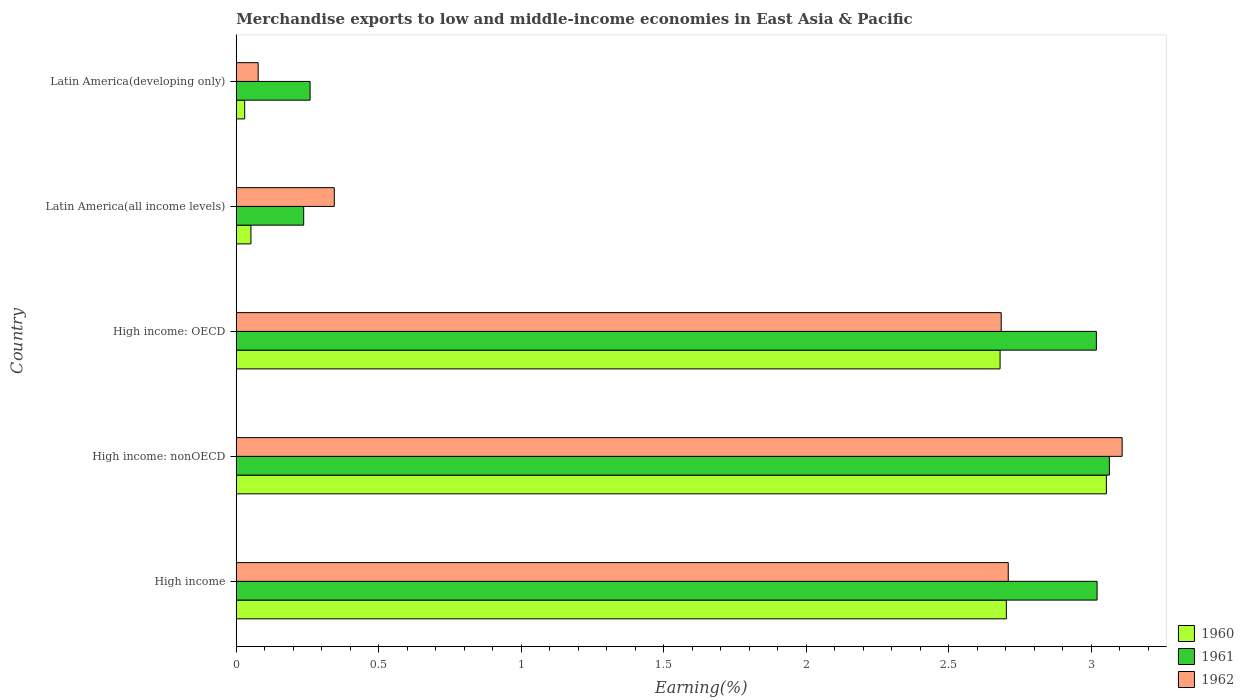How many different coloured bars are there?
Your response must be concise. 3. How many groups of bars are there?
Offer a very short reply. 5. How many bars are there on the 1st tick from the top?
Keep it short and to the point. 3. What is the label of the 2nd group of bars from the top?
Offer a very short reply. Latin America(all income levels). In how many cases, is the number of bars for a given country not equal to the number of legend labels?
Your answer should be compact. 0. What is the percentage of amount earned from merchandise exports in 1960 in High income: nonOECD?
Keep it short and to the point. 3.05. Across all countries, what is the maximum percentage of amount earned from merchandise exports in 1961?
Provide a short and direct response. 3.06. Across all countries, what is the minimum percentage of amount earned from merchandise exports in 1960?
Keep it short and to the point. 0.03. In which country was the percentage of amount earned from merchandise exports in 1961 maximum?
Your response must be concise. High income: nonOECD. In which country was the percentage of amount earned from merchandise exports in 1960 minimum?
Give a very brief answer. Latin America(developing only). What is the total percentage of amount earned from merchandise exports in 1962 in the graph?
Offer a very short reply. 8.92. What is the difference between the percentage of amount earned from merchandise exports in 1961 in Latin America(all income levels) and that in Latin America(developing only)?
Your answer should be compact. -0.02. What is the difference between the percentage of amount earned from merchandise exports in 1960 in High income: OECD and the percentage of amount earned from merchandise exports in 1961 in Latin America(all income levels)?
Your response must be concise. 2.44. What is the average percentage of amount earned from merchandise exports in 1961 per country?
Your response must be concise. 1.92. What is the difference between the percentage of amount earned from merchandise exports in 1960 and percentage of amount earned from merchandise exports in 1962 in High income?
Your answer should be very brief. -0.01. In how many countries, is the percentage of amount earned from merchandise exports in 1961 greater than 1 %?
Your answer should be very brief. 3. What is the ratio of the percentage of amount earned from merchandise exports in 1961 in High income to that in Latin America(all income levels)?
Your answer should be very brief. 12.76. Is the difference between the percentage of amount earned from merchandise exports in 1960 in High income: OECD and Latin America(all income levels) greater than the difference between the percentage of amount earned from merchandise exports in 1962 in High income: OECD and Latin America(all income levels)?
Provide a succinct answer. Yes. What is the difference between the highest and the second highest percentage of amount earned from merchandise exports in 1960?
Give a very brief answer. 0.35. What is the difference between the highest and the lowest percentage of amount earned from merchandise exports in 1960?
Offer a terse response. 3.02. What does the 1st bar from the top in High income: nonOECD represents?
Ensure brevity in your answer.  1962. What does the 2nd bar from the bottom in High income: nonOECD represents?
Provide a succinct answer. 1961. How many bars are there?
Give a very brief answer. 15. Are all the bars in the graph horizontal?
Keep it short and to the point. Yes. How many countries are there in the graph?
Offer a terse response. 5. What is the difference between two consecutive major ticks on the X-axis?
Offer a very short reply. 0.5. How many legend labels are there?
Your answer should be compact. 3. How are the legend labels stacked?
Make the answer very short. Vertical. What is the title of the graph?
Give a very brief answer. Merchandise exports to low and middle-income economies in East Asia & Pacific. Does "1966" appear as one of the legend labels in the graph?
Make the answer very short. No. What is the label or title of the X-axis?
Keep it short and to the point. Earning(%). What is the label or title of the Y-axis?
Give a very brief answer. Country. What is the Earning(%) in 1960 in High income?
Provide a short and direct response. 2.7. What is the Earning(%) of 1961 in High income?
Give a very brief answer. 3.02. What is the Earning(%) in 1962 in High income?
Provide a succinct answer. 2.71. What is the Earning(%) of 1960 in High income: nonOECD?
Your answer should be very brief. 3.05. What is the Earning(%) in 1961 in High income: nonOECD?
Make the answer very short. 3.06. What is the Earning(%) in 1962 in High income: nonOECD?
Keep it short and to the point. 3.11. What is the Earning(%) of 1960 in High income: OECD?
Ensure brevity in your answer.  2.68. What is the Earning(%) in 1961 in High income: OECD?
Provide a short and direct response. 3.02. What is the Earning(%) of 1962 in High income: OECD?
Your answer should be very brief. 2.68. What is the Earning(%) in 1960 in Latin America(all income levels)?
Offer a very short reply. 0.05. What is the Earning(%) of 1961 in Latin America(all income levels)?
Keep it short and to the point. 0.24. What is the Earning(%) of 1962 in Latin America(all income levels)?
Offer a terse response. 0.34. What is the Earning(%) of 1960 in Latin America(developing only)?
Your answer should be compact. 0.03. What is the Earning(%) in 1961 in Latin America(developing only)?
Make the answer very short. 0.26. What is the Earning(%) of 1962 in Latin America(developing only)?
Provide a short and direct response. 0.08. Across all countries, what is the maximum Earning(%) in 1960?
Keep it short and to the point. 3.05. Across all countries, what is the maximum Earning(%) in 1961?
Your answer should be compact. 3.06. Across all countries, what is the maximum Earning(%) of 1962?
Your answer should be compact. 3.11. Across all countries, what is the minimum Earning(%) of 1960?
Offer a very short reply. 0.03. Across all countries, what is the minimum Earning(%) of 1961?
Provide a succinct answer. 0.24. Across all countries, what is the minimum Earning(%) of 1962?
Keep it short and to the point. 0.08. What is the total Earning(%) of 1960 in the graph?
Offer a very short reply. 8.52. What is the total Earning(%) in 1961 in the graph?
Offer a terse response. 9.6. What is the total Earning(%) of 1962 in the graph?
Ensure brevity in your answer.  8.92. What is the difference between the Earning(%) of 1960 in High income and that in High income: nonOECD?
Ensure brevity in your answer.  -0.35. What is the difference between the Earning(%) of 1961 in High income and that in High income: nonOECD?
Offer a very short reply. -0.04. What is the difference between the Earning(%) of 1962 in High income and that in High income: nonOECD?
Offer a terse response. -0.4. What is the difference between the Earning(%) in 1960 in High income and that in High income: OECD?
Give a very brief answer. 0.02. What is the difference between the Earning(%) in 1961 in High income and that in High income: OECD?
Keep it short and to the point. 0. What is the difference between the Earning(%) in 1962 in High income and that in High income: OECD?
Your answer should be compact. 0.02. What is the difference between the Earning(%) of 1960 in High income and that in Latin America(all income levels)?
Keep it short and to the point. 2.65. What is the difference between the Earning(%) of 1961 in High income and that in Latin America(all income levels)?
Make the answer very short. 2.78. What is the difference between the Earning(%) of 1962 in High income and that in Latin America(all income levels)?
Offer a terse response. 2.37. What is the difference between the Earning(%) of 1960 in High income and that in Latin America(developing only)?
Offer a terse response. 2.67. What is the difference between the Earning(%) of 1961 in High income and that in Latin America(developing only)?
Ensure brevity in your answer.  2.76. What is the difference between the Earning(%) of 1962 in High income and that in Latin America(developing only)?
Your answer should be compact. 2.63. What is the difference between the Earning(%) in 1960 in High income: nonOECD and that in High income: OECD?
Keep it short and to the point. 0.37. What is the difference between the Earning(%) of 1961 in High income: nonOECD and that in High income: OECD?
Ensure brevity in your answer.  0.05. What is the difference between the Earning(%) in 1962 in High income: nonOECD and that in High income: OECD?
Give a very brief answer. 0.42. What is the difference between the Earning(%) of 1960 in High income: nonOECD and that in Latin America(all income levels)?
Offer a very short reply. 3. What is the difference between the Earning(%) of 1961 in High income: nonOECD and that in Latin America(all income levels)?
Give a very brief answer. 2.83. What is the difference between the Earning(%) of 1962 in High income: nonOECD and that in Latin America(all income levels)?
Provide a short and direct response. 2.76. What is the difference between the Earning(%) in 1960 in High income: nonOECD and that in Latin America(developing only)?
Offer a very short reply. 3.02. What is the difference between the Earning(%) of 1961 in High income: nonOECD and that in Latin America(developing only)?
Keep it short and to the point. 2.8. What is the difference between the Earning(%) of 1962 in High income: nonOECD and that in Latin America(developing only)?
Keep it short and to the point. 3.03. What is the difference between the Earning(%) of 1960 in High income: OECD and that in Latin America(all income levels)?
Give a very brief answer. 2.63. What is the difference between the Earning(%) of 1961 in High income: OECD and that in Latin America(all income levels)?
Give a very brief answer. 2.78. What is the difference between the Earning(%) of 1962 in High income: OECD and that in Latin America(all income levels)?
Make the answer very short. 2.34. What is the difference between the Earning(%) of 1960 in High income: OECD and that in Latin America(developing only)?
Provide a short and direct response. 2.65. What is the difference between the Earning(%) of 1961 in High income: OECD and that in Latin America(developing only)?
Your response must be concise. 2.76. What is the difference between the Earning(%) of 1962 in High income: OECD and that in Latin America(developing only)?
Your answer should be compact. 2.61. What is the difference between the Earning(%) of 1960 in Latin America(all income levels) and that in Latin America(developing only)?
Keep it short and to the point. 0.02. What is the difference between the Earning(%) of 1961 in Latin America(all income levels) and that in Latin America(developing only)?
Keep it short and to the point. -0.02. What is the difference between the Earning(%) of 1962 in Latin America(all income levels) and that in Latin America(developing only)?
Keep it short and to the point. 0.27. What is the difference between the Earning(%) in 1960 in High income and the Earning(%) in 1961 in High income: nonOECD?
Keep it short and to the point. -0.36. What is the difference between the Earning(%) of 1960 in High income and the Earning(%) of 1962 in High income: nonOECD?
Provide a succinct answer. -0.41. What is the difference between the Earning(%) in 1961 in High income and the Earning(%) in 1962 in High income: nonOECD?
Provide a short and direct response. -0.09. What is the difference between the Earning(%) in 1960 in High income and the Earning(%) in 1961 in High income: OECD?
Your answer should be compact. -0.32. What is the difference between the Earning(%) of 1960 in High income and the Earning(%) of 1962 in High income: OECD?
Ensure brevity in your answer.  0.02. What is the difference between the Earning(%) in 1961 in High income and the Earning(%) in 1962 in High income: OECD?
Provide a succinct answer. 0.34. What is the difference between the Earning(%) in 1960 in High income and the Earning(%) in 1961 in Latin America(all income levels)?
Give a very brief answer. 2.47. What is the difference between the Earning(%) in 1960 in High income and the Earning(%) in 1962 in Latin America(all income levels)?
Offer a very short reply. 2.36. What is the difference between the Earning(%) of 1961 in High income and the Earning(%) of 1962 in Latin America(all income levels)?
Ensure brevity in your answer.  2.68. What is the difference between the Earning(%) of 1960 in High income and the Earning(%) of 1961 in Latin America(developing only)?
Ensure brevity in your answer.  2.44. What is the difference between the Earning(%) of 1960 in High income and the Earning(%) of 1962 in Latin America(developing only)?
Your answer should be compact. 2.63. What is the difference between the Earning(%) of 1961 in High income and the Earning(%) of 1962 in Latin America(developing only)?
Your answer should be compact. 2.94. What is the difference between the Earning(%) in 1960 in High income: nonOECD and the Earning(%) in 1961 in High income: OECD?
Provide a succinct answer. 0.04. What is the difference between the Earning(%) of 1960 in High income: nonOECD and the Earning(%) of 1962 in High income: OECD?
Offer a terse response. 0.37. What is the difference between the Earning(%) of 1961 in High income: nonOECD and the Earning(%) of 1962 in High income: OECD?
Provide a short and direct response. 0.38. What is the difference between the Earning(%) in 1960 in High income: nonOECD and the Earning(%) in 1961 in Latin America(all income levels)?
Offer a very short reply. 2.82. What is the difference between the Earning(%) of 1960 in High income: nonOECD and the Earning(%) of 1962 in Latin America(all income levels)?
Your response must be concise. 2.71. What is the difference between the Earning(%) of 1961 in High income: nonOECD and the Earning(%) of 1962 in Latin America(all income levels)?
Provide a short and direct response. 2.72. What is the difference between the Earning(%) in 1960 in High income: nonOECD and the Earning(%) in 1961 in Latin America(developing only)?
Your response must be concise. 2.79. What is the difference between the Earning(%) in 1960 in High income: nonOECD and the Earning(%) in 1962 in Latin America(developing only)?
Provide a short and direct response. 2.98. What is the difference between the Earning(%) in 1961 in High income: nonOECD and the Earning(%) in 1962 in Latin America(developing only)?
Ensure brevity in your answer.  2.99. What is the difference between the Earning(%) of 1960 in High income: OECD and the Earning(%) of 1961 in Latin America(all income levels)?
Offer a very short reply. 2.44. What is the difference between the Earning(%) in 1960 in High income: OECD and the Earning(%) in 1962 in Latin America(all income levels)?
Keep it short and to the point. 2.34. What is the difference between the Earning(%) in 1961 in High income: OECD and the Earning(%) in 1962 in Latin America(all income levels)?
Your answer should be compact. 2.67. What is the difference between the Earning(%) in 1960 in High income: OECD and the Earning(%) in 1961 in Latin America(developing only)?
Provide a short and direct response. 2.42. What is the difference between the Earning(%) in 1960 in High income: OECD and the Earning(%) in 1962 in Latin America(developing only)?
Provide a succinct answer. 2.6. What is the difference between the Earning(%) of 1961 in High income: OECD and the Earning(%) of 1962 in Latin America(developing only)?
Your answer should be very brief. 2.94. What is the difference between the Earning(%) in 1960 in Latin America(all income levels) and the Earning(%) in 1961 in Latin America(developing only)?
Give a very brief answer. -0.21. What is the difference between the Earning(%) in 1960 in Latin America(all income levels) and the Earning(%) in 1962 in Latin America(developing only)?
Provide a succinct answer. -0.03. What is the difference between the Earning(%) in 1961 in Latin America(all income levels) and the Earning(%) in 1962 in Latin America(developing only)?
Provide a short and direct response. 0.16. What is the average Earning(%) in 1960 per country?
Provide a short and direct response. 1.7. What is the average Earning(%) in 1961 per country?
Provide a succinct answer. 1.92. What is the average Earning(%) of 1962 per country?
Offer a terse response. 1.78. What is the difference between the Earning(%) of 1960 and Earning(%) of 1961 in High income?
Ensure brevity in your answer.  -0.32. What is the difference between the Earning(%) of 1960 and Earning(%) of 1962 in High income?
Provide a succinct answer. -0.01. What is the difference between the Earning(%) of 1961 and Earning(%) of 1962 in High income?
Ensure brevity in your answer.  0.31. What is the difference between the Earning(%) of 1960 and Earning(%) of 1961 in High income: nonOECD?
Offer a very short reply. -0.01. What is the difference between the Earning(%) in 1960 and Earning(%) in 1962 in High income: nonOECD?
Provide a succinct answer. -0.06. What is the difference between the Earning(%) of 1961 and Earning(%) of 1962 in High income: nonOECD?
Keep it short and to the point. -0.04. What is the difference between the Earning(%) in 1960 and Earning(%) in 1961 in High income: OECD?
Offer a very short reply. -0.34. What is the difference between the Earning(%) of 1960 and Earning(%) of 1962 in High income: OECD?
Ensure brevity in your answer.  -0. What is the difference between the Earning(%) of 1961 and Earning(%) of 1962 in High income: OECD?
Keep it short and to the point. 0.33. What is the difference between the Earning(%) in 1960 and Earning(%) in 1961 in Latin America(all income levels)?
Provide a short and direct response. -0.19. What is the difference between the Earning(%) in 1960 and Earning(%) in 1962 in Latin America(all income levels)?
Your answer should be very brief. -0.29. What is the difference between the Earning(%) of 1961 and Earning(%) of 1962 in Latin America(all income levels)?
Your response must be concise. -0.11. What is the difference between the Earning(%) of 1960 and Earning(%) of 1961 in Latin America(developing only)?
Your answer should be very brief. -0.23. What is the difference between the Earning(%) of 1960 and Earning(%) of 1962 in Latin America(developing only)?
Give a very brief answer. -0.05. What is the difference between the Earning(%) in 1961 and Earning(%) in 1962 in Latin America(developing only)?
Keep it short and to the point. 0.18. What is the ratio of the Earning(%) of 1960 in High income to that in High income: nonOECD?
Offer a terse response. 0.89. What is the ratio of the Earning(%) of 1961 in High income to that in High income: nonOECD?
Your answer should be compact. 0.99. What is the ratio of the Earning(%) in 1962 in High income to that in High income: nonOECD?
Your answer should be compact. 0.87. What is the ratio of the Earning(%) of 1960 in High income to that in High income: OECD?
Provide a short and direct response. 1.01. What is the ratio of the Earning(%) in 1962 in High income to that in High income: OECD?
Keep it short and to the point. 1.01. What is the ratio of the Earning(%) of 1960 in High income to that in Latin America(all income levels)?
Offer a very short reply. 52.52. What is the ratio of the Earning(%) of 1961 in High income to that in Latin America(all income levels)?
Provide a succinct answer. 12.76. What is the ratio of the Earning(%) in 1962 in High income to that in Latin America(all income levels)?
Provide a short and direct response. 7.87. What is the ratio of the Earning(%) in 1960 in High income to that in Latin America(developing only)?
Your response must be concise. 91.3. What is the ratio of the Earning(%) of 1961 in High income to that in Latin America(developing only)?
Provide a succinct answer. 11.66. What is the ratio of the Earning(%) of 1962 in High income to that in Latin America(developing only)?
Offer a terse response. 35.22. What is the ratio of the Earning(%) in 1960 in High income: nonOECD to that in High income: OECD?
Give a very brief answer. 1.14. What is the ratio of the Earning(%) in 1961 in High income: nonOECD to that in High income: OECD?
Keep it short and to the point. 1.02. What is the ratio of the Earning(%) in 1962 in High income: nonOECD to that in High income: OECD?
Your answer should be very brief. 1.16. What is the ratio of the Earning(%) of 1960 in High income: nonOECD to that in Latin America(all income levels)?
Your answer should be compact. 59.34. What is the ratio of the Earning(%) in 1961 in High income: nonOECD to that in Latin America(all income levels)?
Ensure brevity in your answer.  12.95. What is the ratio of the Earning(%) in 1962 in High income: nonOECD to that in Latin America(all income levels)?
Provide a succinct answer. 9.04. What is the ratio of the Earning(%) of 1960 in High income: nonOECD to that in Latin America(developing only)?
Ensure brevity in your answer.  103.16. What is the ratio of the Earning(%) in 1961 in High income: nonOECD to that in Latin America(developing only)?
Make the answer very short. 11.82. What is the ratio of the Earning(%) of 1962 in High income: nonOECD to that in Latin America(developing only)?
Make the answer very short. 40.41. What is the ratio of the Earning(%) in 1960 in High income: OECD to that in Latin America(all income levels)?
Make the answer very short. 52.09. What is the ratio of the Earning(%) in 1961 in High income: OECD to that in Latin America(all income levels)?
Ensure brevity in your answer.  12.75. What is the ratio of the Earning(%) in 1962 in High income: OECD to that in Latin America(all income levels)?
Your answer should be compact. 7.8. What is the ratio of the Earning(%) in 1960 in High income: OECD to that in Latin America(developing only)?
Offer a terse response. 90.55. What is the ratio of the Earning(%) in 1961 in High income: OECD to that in Latin America(developing only)?
Ensure brevity in your answer.  11.65. What is the ratio of the Earning(%) in 1962 in High income: OECD to that in Latin America(developing only)?
Make the answer very short. 34.9. What is the ratio of the Earning(%) in 1960 in Latin America(all income levels) to that in Latin America(developing only)?
Ensure brevity in your answer.  1.74. What is the ratio of the Earning(%) in 1961 in Latin America(all income levels) to that in Latin America(developing only)?
Offer a very short reply. 0.91. What is the ratio of the Earning(%) in 1962 in Latin America(all income levels) to that in Latin America(developing only)?
Make the answer very short. 4.47. What is the difference between the highest and the second highest Earning(%) in 1960?
Your answer should be compact. 0.35. What is the difference between the highest and the second highest Earning(%) in 1961?
Your answer should be compact. 0.04. What is the difference between the highest and the second highest Earning(%) in 1962?
Make the answer very short. 0.4. What is the difference between the highest and the lowest Earning(%) in 1960?
Provide a short and direct response. 3.02. What is the difference between the highest and the lowest Earning(%) in 1961?
Provide a short and direct response. 2.83. What is the difference between the highest and the lowest Earning(%) in 1962?
Offer a very short reply. 3.03. 